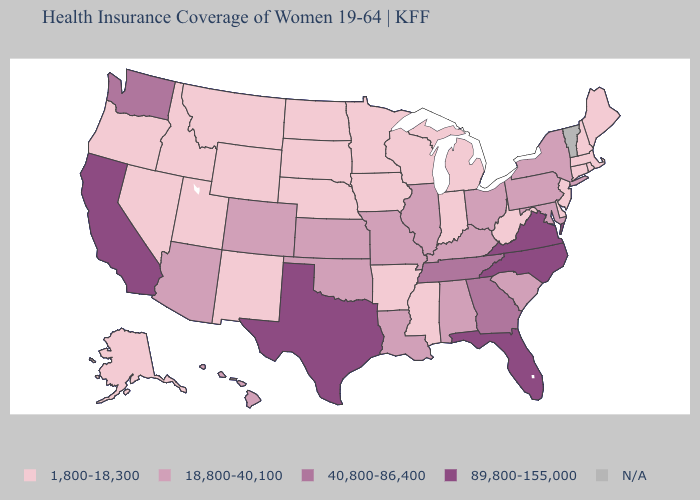What is the lowest value in states that border Oklahoma?
Give a very brief answer. 1,800-18,300. Does Connecticut have the highest value in the Northeast?
Write a very short answer. No. What is the value of Pennsylvania?
Quick response, please. 18,800-40,100. What is the value of New Jersey?
Keep it brief. 1,800-18,300. Which states have the lowest value in the USA?
Give a very brief answer. Alaska, Arkansas, Connecticut, Delaware, Idaho, Indiana, Iowa, Maine, Massachusetts, Michigan, Minnesota, Mississippi, Montana, Nebraska, Nevada, New Hampshire, New Jersey, New Mexico, North Dakota, Oregon, Rhode Island, South Dakota, Utah, West Virginia, Wisconsin, Wyoming. Which states have the lowest value in the South?
Give a very brief answer. Arkansas, Delaware, Mississippi, West Virginia. Name the states that have a value in the range 89,800-155,000?
Be succinct. California, Florida, North Carolina, Texas, Virginia. What is the value of California?
Give a very brief answer. 89,800-155,000. What is the value of Wyoming?
Be succinct. 1,800-18,300. Name the states that have a value in the range 1,800-18,300?
Write a very short answer. Alaska, Arkansas, Connecticut, Delaware, Idaho, Indiana, Iowa, Maine, Massachusetts, Michigan, Minnesota, Mississippi, Montana, Nebraska, Nevada, New Hampshire, New Jersey, New Mexico, North Dakota, Oregon, Rhode Island, South Dakota, Utah, West Virginia, Wisconsin, Wyoming. What is the lowest value in the Northeast?
Concise answer only. 1,800-18,300. What is the value of Indiana?
Keep it brief. 1,800-18,300. Name the states that have a value in the range N/A?
Short answer required. Vermont. What is the lowest value in the USA?
Keep it brief. 1,800-18,300. Which states have the highest value in the USA?
Be succinct. California, Florida, North Carolina, Texas, Virginia. 